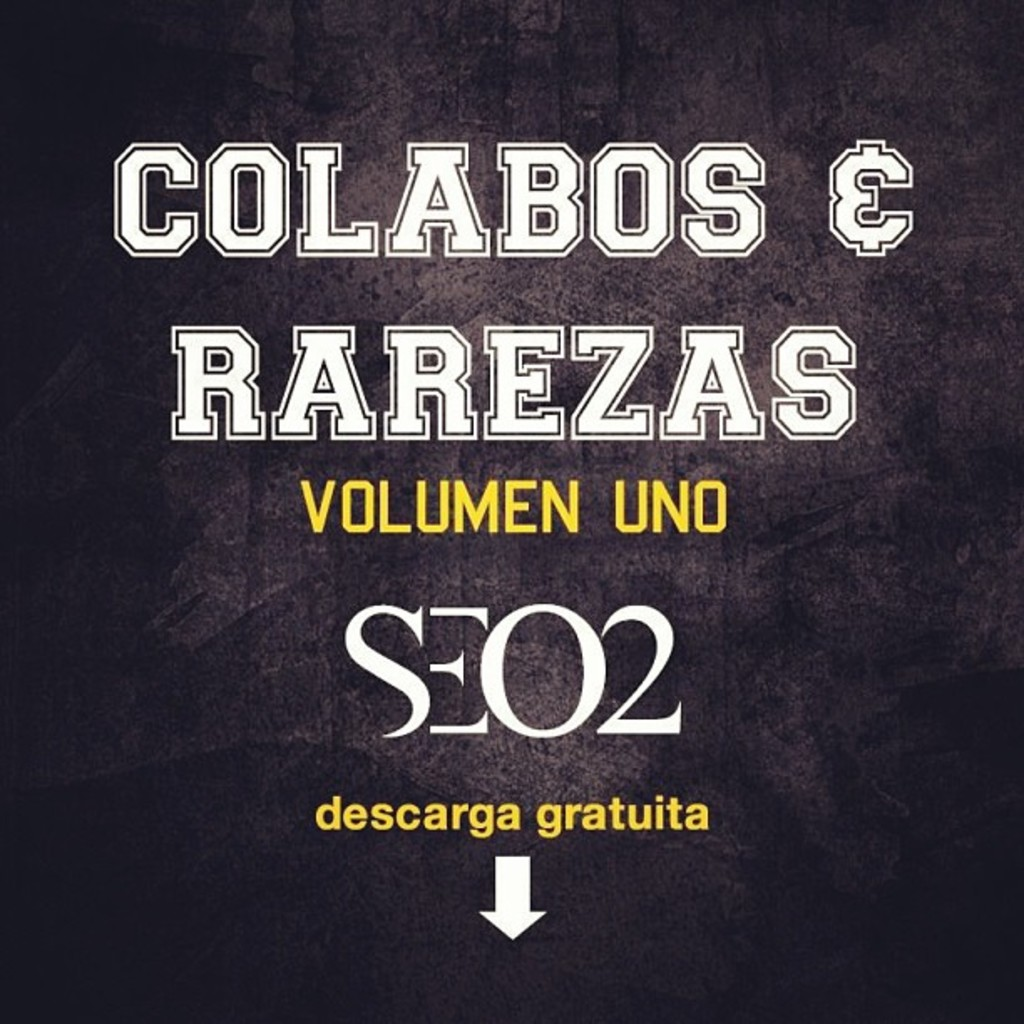What do you think the downward arrow at the bottom signifies? The downward arrow at the bottom of the album cover likely serves as a direct visual cue for the phrase 'descarga gratuita,' which translates to 'free download.' It visually guides viewers towards this important feature, emphasizing that the album can be downloaded at no cost, which could be a key selling point. The arrow's simplistic but prominent design ensures it is both noticeable and understandable, efficiently communicating its message. 